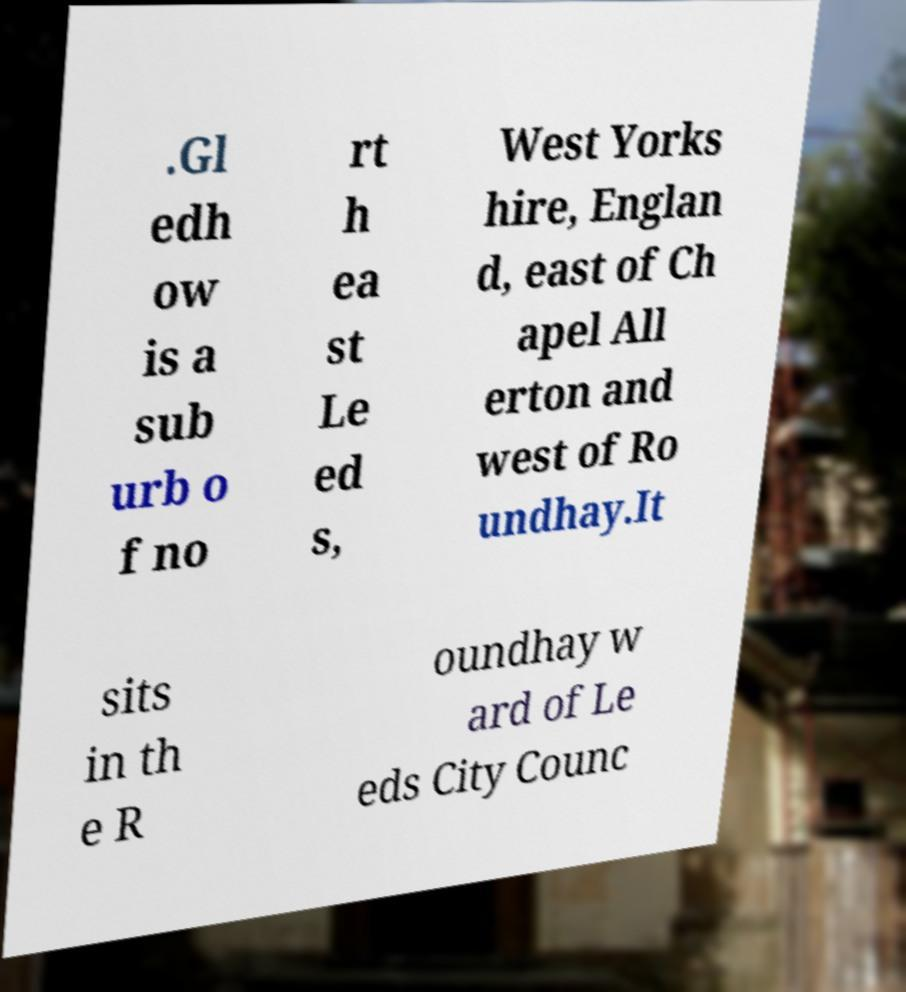Could you assist in decoding the text presented in this image and type it out clearly? .Gl edh ow is a sub urb o f no rt h ea st Le ed s, West Yorks hire, Englan d, east of Ch apel All erton and west of Ro undhay.It sits in th e R oundhay w ard of Le eds City Counc 